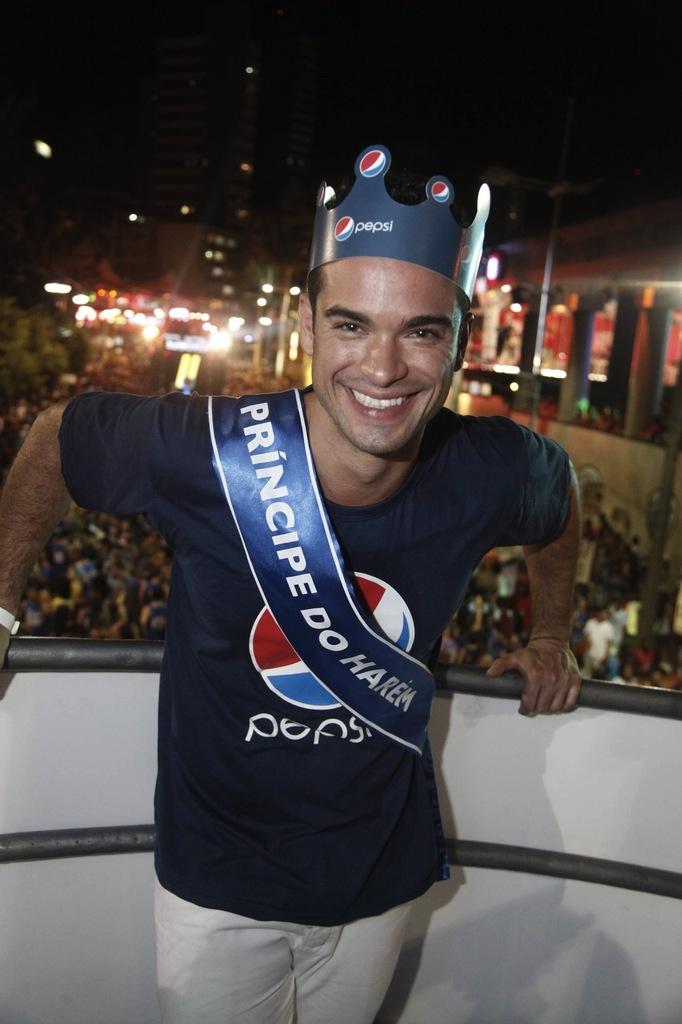What brand logo is on his shirt?
Provide a succinct answer. Pepsi. 